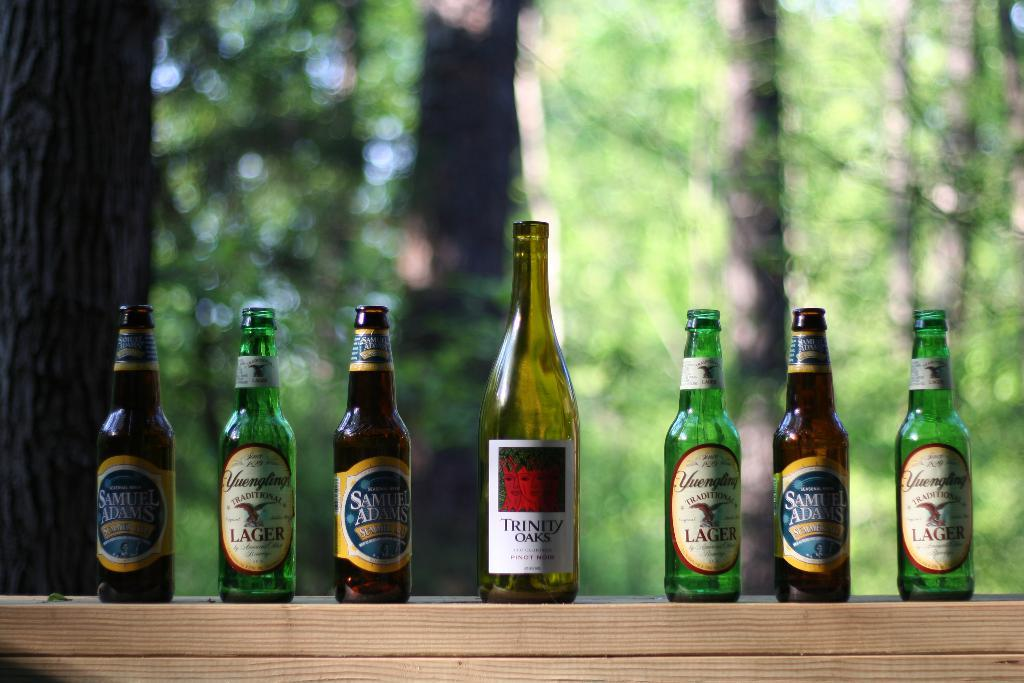<image>
Provide a brief description of the given image. A series of seven bottles are lined up with the tallest bottle labeled Trinity Oaks in the center. 